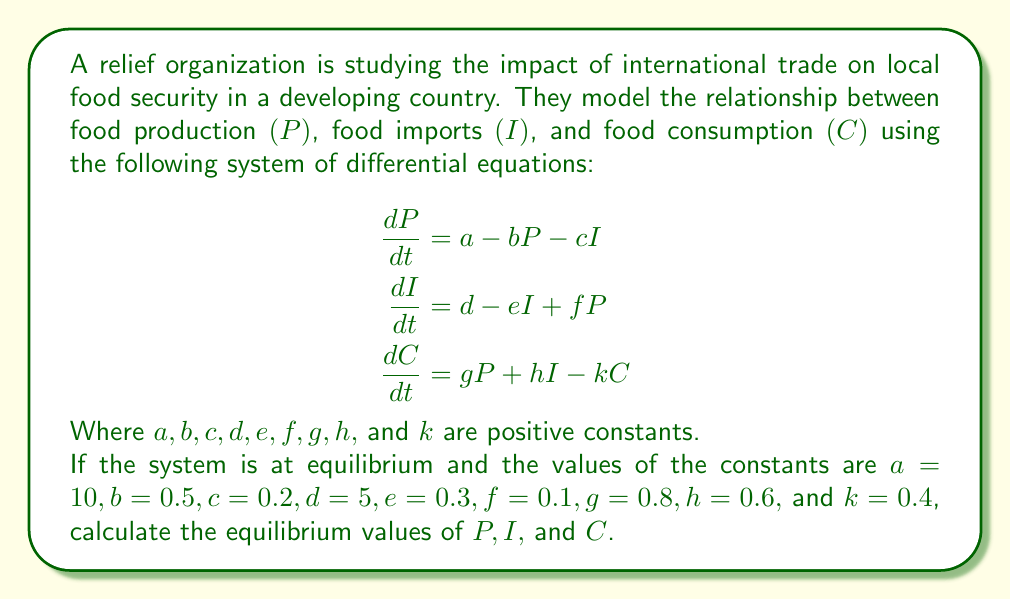Solve this math problem. To solve this problem, we need to follow these steps:

1) At equilibrium, the rate of change for each variable is zero. So, we set each differential equation to zero:

   $$\begin{aligned}
   0 &= a - bP - cI \\
   0 &= d - eI + fP \\
   0 &= gP + hI - kC
   \end{aligned}$$

2) Substitute the given values:

   $$\begin{aligned}
   0 &= 10 - 0.5P - 0.2I \\
   0 &= 5 - 0.3I + 0.1P \\
   0 &= 0.8P + 0.6I - 0.4C
   \end{aligned}$$

3) From the first equation:
   
   $10 - 0.5P - 0.2I = 0$
   $20 - P - 0.4I = 0$ (multiplied by 2)
   $P = 20 - 0.4I$ ... (Equation 1)

4) Substitute this into the second equation:

   $0 = 5 - 0.3I + 0.1(20 - 0.4I)$
   $0 = 5 - 0.3I + 2 - 0.04I$
   $0 = 7 - 0.34I$
   $I = 7 / 0.34 = 20.5882$

5) Substitute this value of $I$ back into Equation 1:

   $P = 20 - 0.4(20.5882) = 11.7647$

6) Now use these values in the third equation to find $C$:

   $0 = 0.8(11.7647) + 0.6(20.5882) - 0.4C$
   $0 = 9.4118 + 12.3529 - 0.4C$
   $0.4C = 21.7647$
   $C = 54.4118$

Therefore, the equilibrium values are:
$P = 11.7647$, $I = 20.5882$, and $C = 54.4118$.
Answer: The equilibrium values are: $P = 11.7647$, $I = 20.5882$, and $C = 54.4118$. 